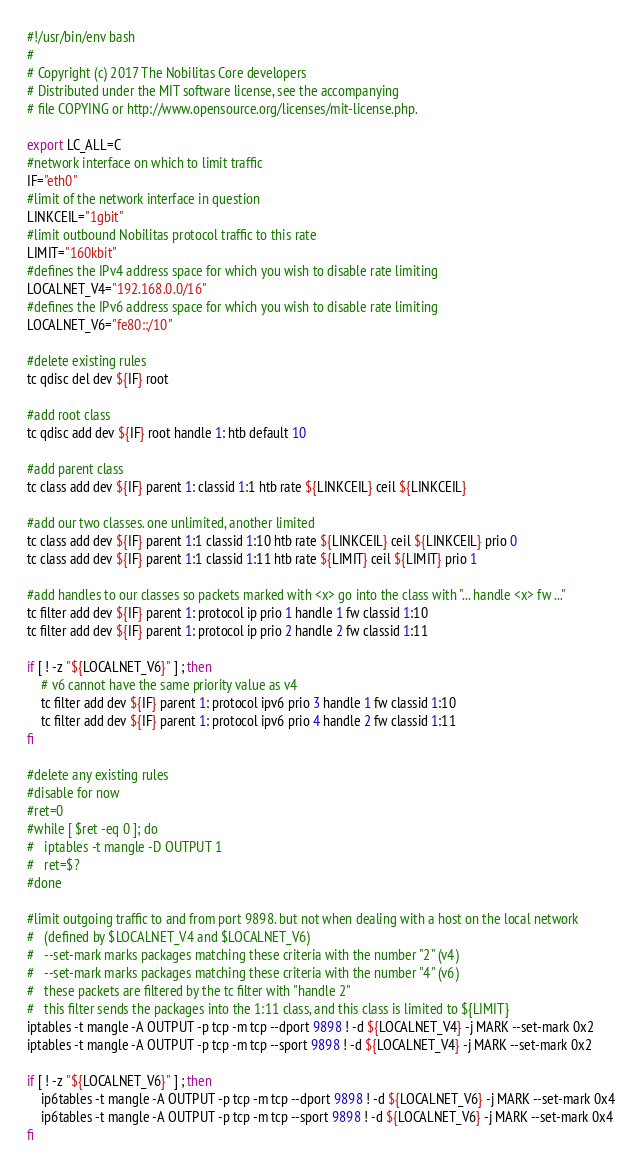<code> <loc_0><loc_0><loc_500><loc_500><_Bash_>#!/usr/bin/env bash
#
# Copyright (c) 2017 The Nobilitas Core developers
# Distributed under the MIT software license, see the accompanying
# file COPYING or http://www.opensource.org/licenses/mit-license.php.

export LC_ALL=C
#network interface on which to limit traffic
IF="eth0"
#limit of the network interface in question
LINKCEIL="1gbit"
#limit outbound Nobilitas protocol traffic to this rate
LIMIT="160kbit"
#defines the IPv4 address space for which you wish to disable rate limiting
LOCALNET_V4="192.168.0.0/16"
#defines the IPv6 address space for which you wish to disable rate limiting
LOCALNET_V6="fe80::/10"

#delete existing rules
tc qdisc del dev ${IF} root

#add root class
tc qdisc add dev ${IF} root handle 1: htb default 10

#add parent class
tc class add dev ${IF} parent 1: classid 1:1 htb rate ${LINKCEIL} ceil ${LINKCEIL}

#add our two classes. one unlimited, another limited
tc class add dev ${IF} parent 1:1 classid 1:10 htb rate ${LINKCEIL} ceil ${LINKCEIL} prio 0
tc class add dev ${IF} parent 1:1 classid 1:11 htb rate ${LIMIT} ceil ${LIMIT} prio 1

#add handles to our classes so packets marked with <x> go into the class with "... handle <x> fw ..."
tc filter add dev ${IF} parent 1: protocol ip prio 1 handle 1 fw classid 1:10
tc filter add dev ${IF} parent 1: protocol ip prio 2 handle 2 fw classid 1:11

if [ ! -z "${LOCALNET_V6}" ] ; then
	# v6 cannot have the same priority value as v4
	tc filter add dev ${IF} parent 1: protocol ipv6 prio 3 handle 1 fw classid 1:10
	tc filter add dev ${IF} parent 1: protocol ipv6 prio 4 handle 2 fw classid 1:11
fi

#delete any existing rules
#disable for now
#ret=0
#while [ $ret -eq 0 ]; do
#	iptables -t mangle -D OUTPUT 1
#	ret=$?
#done

#limit outgoing traffic to and from port 9898. but not when dealing with a host on the local network
#	(defined by $LOCALNET_V4 and $LOCALNET_V6)
#	--set-mark marks packages matching these criteria with the number "2" (v4)
#	--set-mark marks packages matching these criteria with the number "4" (v6)
#	these packets are filtered by the tc filter with "handle 2"
#	this filter sends the packages into the 1:11 class, and this class is limited to ${LIMIT}
iptables -t mangle -A OUTPUT -p tcp -m tcp --dport 9898 ! -d ${LOCALNET_V4} -j MARK --set-mark 0x2
iptables -t mangle -A OUTPUT -p tcp -m tcp --sport 9898 ! -d ${LOCALNET_V4} -j MARK --set-mark 0x2

if [ ! -z "${LOCALNET_V6}" ] ; then
	ip6tables -t mangle -A OUTPUT -p tcp -m tcp --dport 9898 ! -d ${LOCALNET_V6} -j MARK --set-mark 0x4
	ip6tables -t mangle -A OUTPUT -p tcp -m tcp --sport 9898 ! -d ${LOCALNET_V6} -j MARK --set-mark 0x4
fi
</code> 